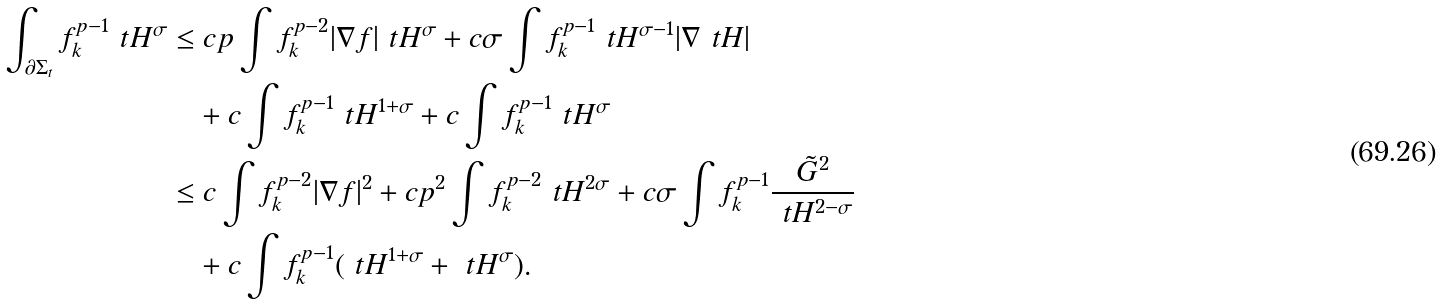Convert formula to latex. <formula><loc_0><loc_0><loc_500><loc_500>\int _ { \partial \Sigma _ { t } } f ^ { p - 1 } _ { k } \ t H ^ { \sigma } & \leq c p \int f ^ { p - 2 } _ { k } | \nabla f | \ t H ^ { \sigma } + c \sigma \int f ^ { p - 1 } _ { k } \ t H ^ { \sigma - 1 } | \nabla \ t H | \\ & \quad + c \int f ^ { p - 1 } _ { k } \ t H ^ { 1 + \sigma } + c \int f ^ { p - 1 } _ { k } \ t H ^ { \sigma } \\ & \leq c \int f ^ { p - 2 } _ { k } | \nabla f | ^ { 2 } + c p ^ { 2 } \int f _ { k } ^ { p - 2 } \ t H ^ { 2 \sigma } + c \sigma \int f _ { k } ^ { p - 1 } \frac { \tilde { G } ^ { 2 } } { \ t H ^ { 2 - \sigma } } \\ & \quad + c \int f _ { k } ^ { p - 1 } ( \ t H ^ { 1 + \sigma } + \ t H ^ { \sigma } ) .</formula> 